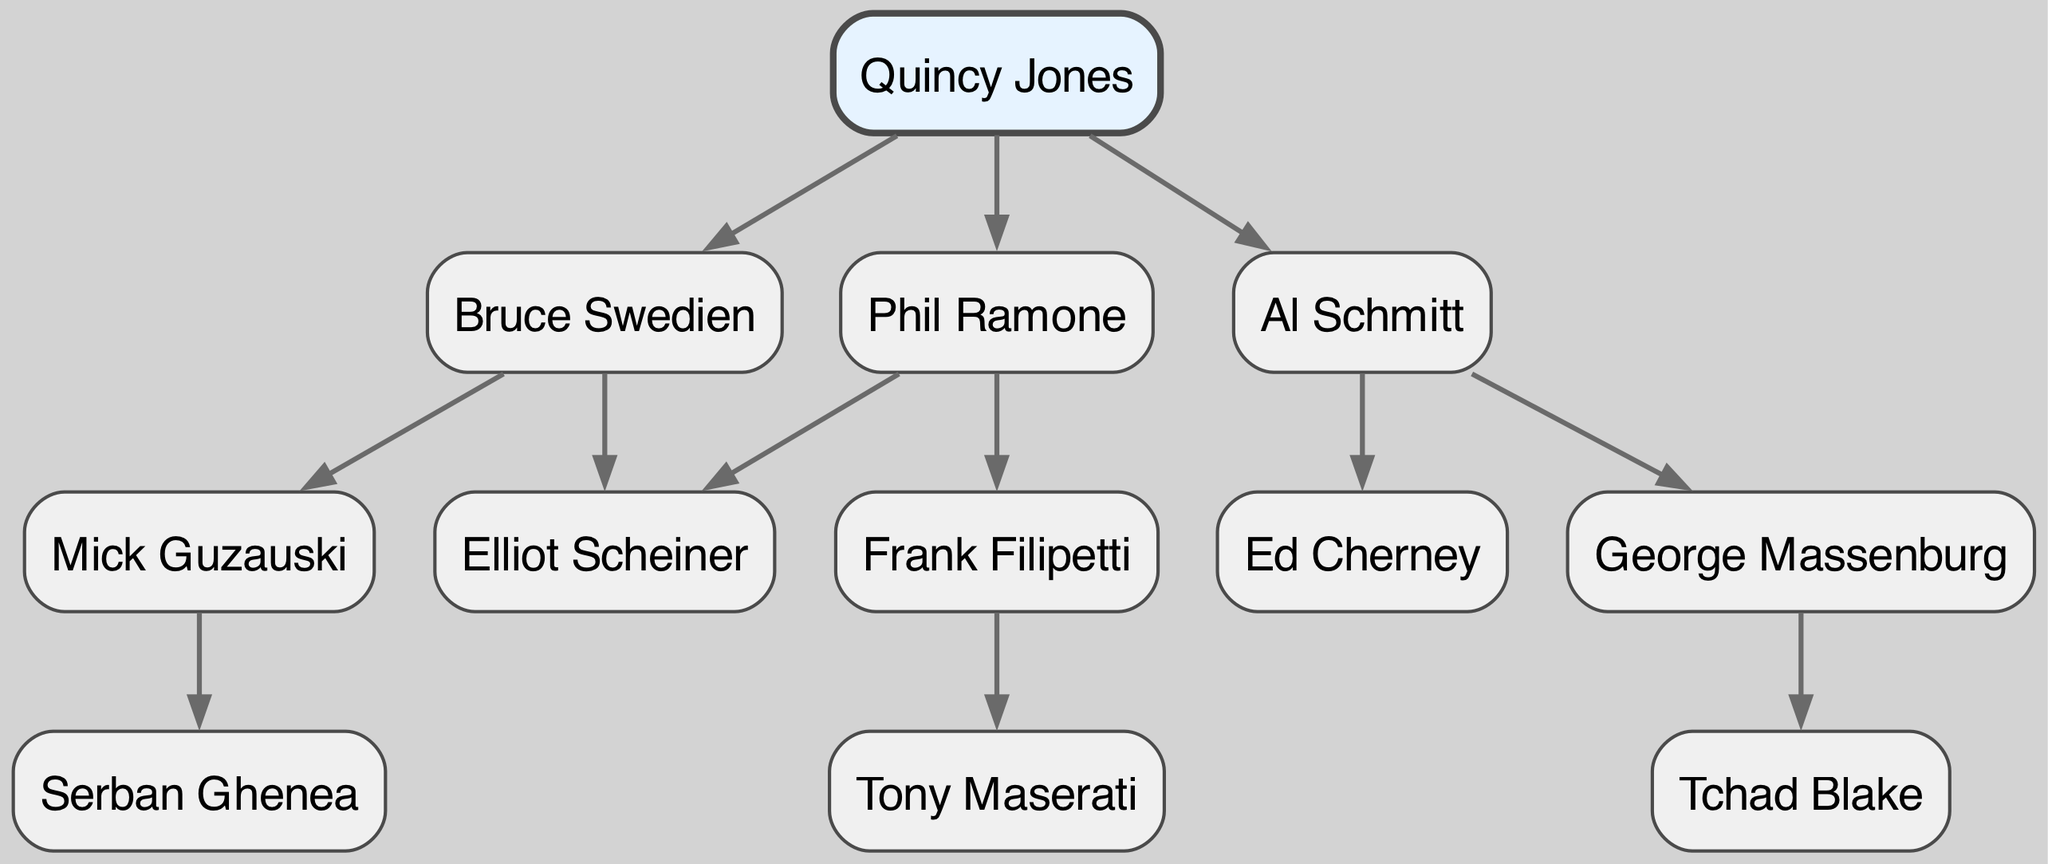What is the root of the family tree? The root of the family tree is the topmost node, which represents the earliest influential figure in this lineage. According to the diagram, the root node is labeled "Quincy Jones."
Answer: Quincy Jones How many children does Bruce Swedien have? Bruce Swedien is depicted as a node with two child nodes, which are "Mick Guzauski" and "Elliot Scheiner." Therefore, the number of children is determined by simply counting these child nodes.
Answer: 2 Who is a direct descendant of Al Schmitt? The descendants of Al Schmitt can be identified by examining his child nodes. Al Schmitt has two children, one of whom is "George Massenburg." Thus, a direct descendant is "George Massenburg."
Answer: George Massenburg Which sound engineer has the most notable influence in this lineage, and who is their protégé? The root node "Quincy Jones" reflects significant influence in the lineage. "Bruce Swedien" is one of his children, and he has a protégé named "Mick Guzauski," who is a further descendant. Thus, Quincy Jones' protégé is "Mick Guzauski."
Answer: Mick Guzauski How many generations are represented in the diagram? The first generation consists of Quincy Jones, making it one level. The second generation is Bruce Swedien, Al Schmitt, and Phil Ramone, forming the second level. The third generation includes their respective children. Therefore, by counting the levels from the root down to the farthest child, there are three distinct generations depicted in the lineage.
Answer: 3 Which sound engineer is the protégé of Frank Filipetti? To find Frank Filipetti's protégé, we look for his children. According to the diagram, Frank Filipetti has one child, which is "Tony Maserati." Hence, Tony Maserati is the protégé of Frank Filipetti.
Answer: Tony Maserati How many unique nodes are present in this family tree? Each sound engineer and producer in the diagram is represented as a unique node. Counting all distinct nodes, including the root and all children, results in a total of eight unique nodes present in the family tree.
Answer: 8 What is the relationship between Serban Ghenea and Quincy Jones? To identify the relationship, we trace the lineage starting from Serban Ghenea to the root. Serban Ghenea is a descendant of Mick Guzauski, who is a child of Bruce Swedien, and Bruce Swedien is a child of Quincy Jones. Therefore, Serban Ghenea is Quincy Jones' grandchild.
Answer: Grandchild 